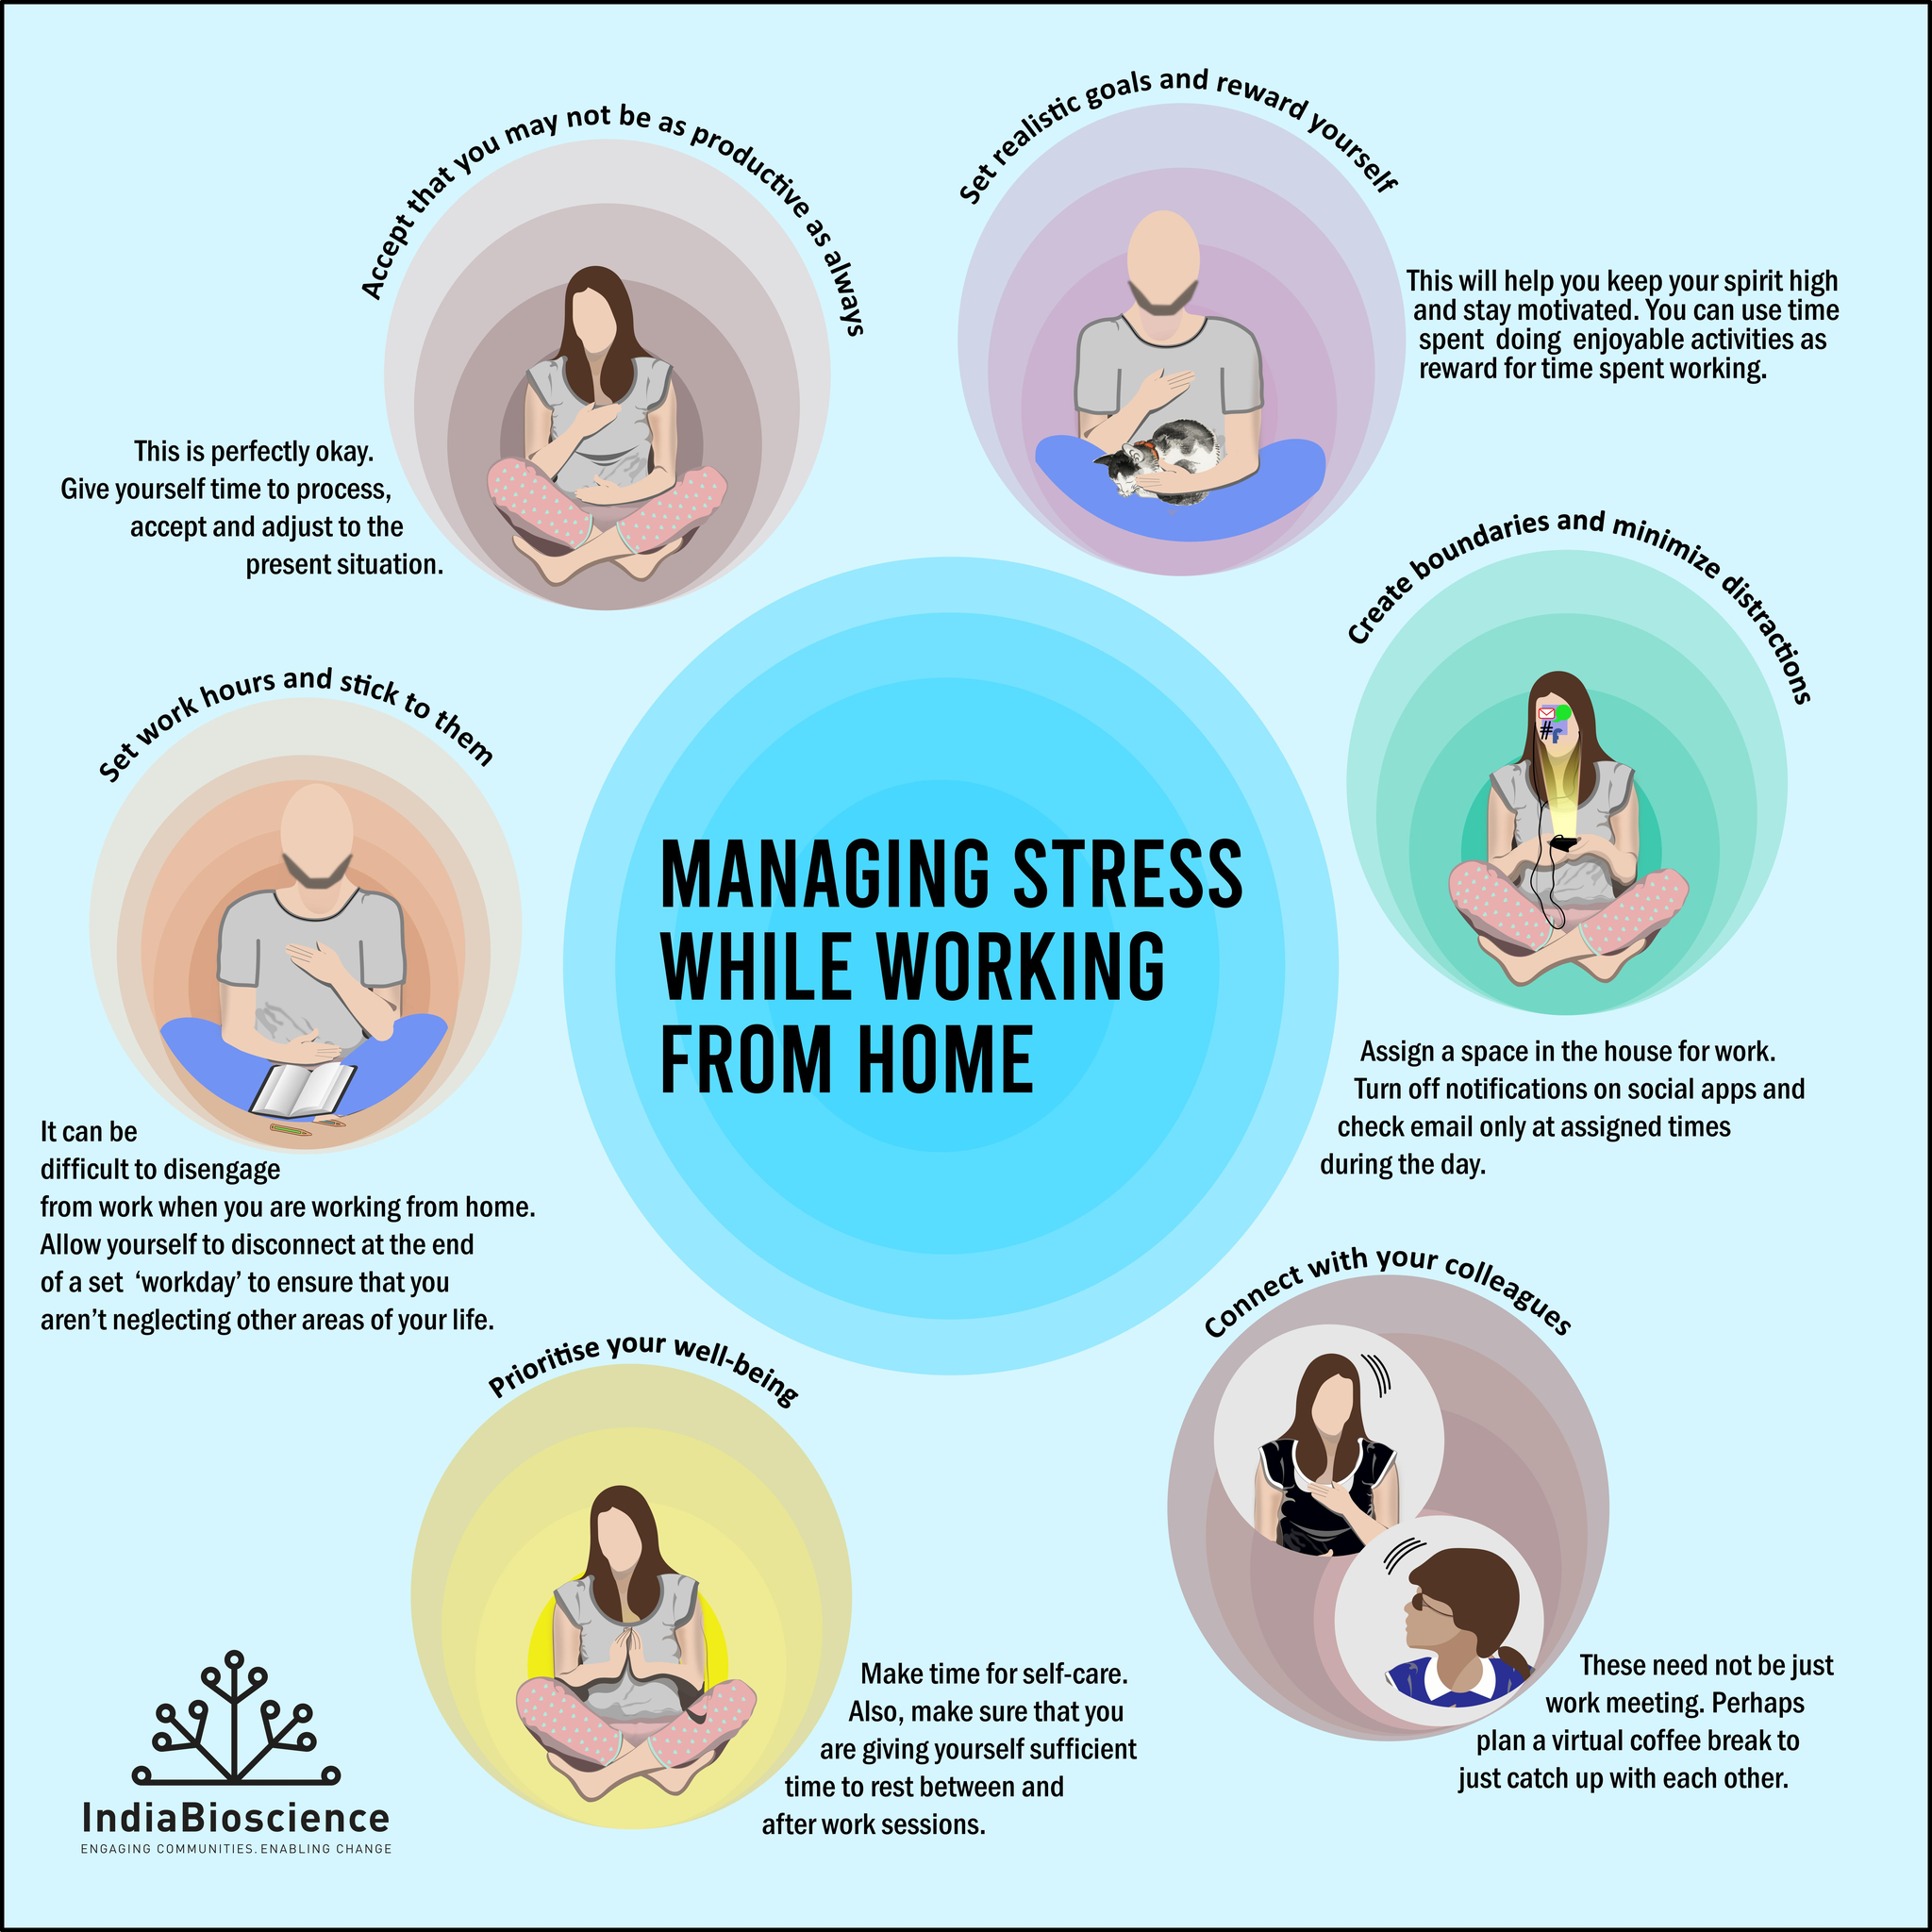List a handful of essential elements in this visual. There are six ways to effectively manage stress while working from home. 